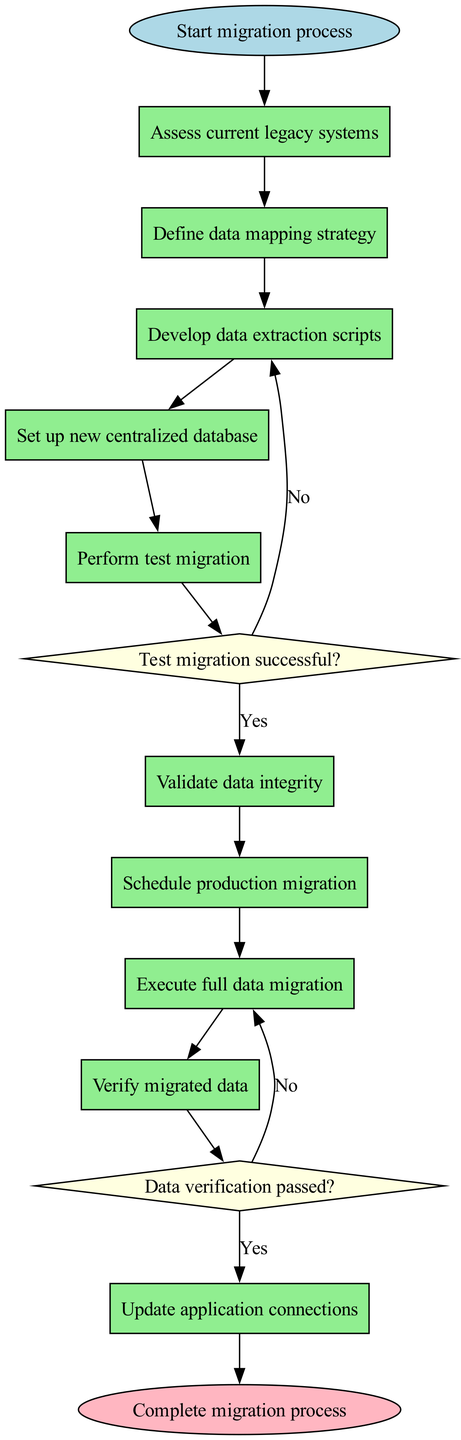What is the first activity in the migration process? The diagram starts with the initial node labeled "Start migration process," which connects to the first activity. The first activity listed in the diagram is "Assess current legacy systems."
Answer: Assess current legacy systems How many activities are in the migration process? The diagram lists a total of ten activities in the migration process from start to finish. By counting each activity listed in the activities array, we find there are ten distinct activities.
Answer: Ten What is the decision made after performing the test migration? After performing the test migration, the decision node asks, "Test migration successful?" If the answer is 'Yes', the next node is "Schedule production migration." If 'No', it connects back to "Refine extraction scripts." The first option is the one that proceeds if successful.
Answer: Schedule production migration Which activity follows after validating data integrity? "Validate data integrity" is the sixth activity in the sequence. The next activity following it is "Schedule production migration," as indicated by the connections in the flow sequence of the diagram.
Answer: Schedule production migration What happens if data verification fails? The diagram shows that if "Data verification passed?" is answered 'No', the next step is "Investigate discrepancies." This flow indicates the corrective measure taken when verification does not meet the required standards.
Answer: Investigate discrepancies How many decision nodes are present in the diagram? There are two decision nodes in the migration procedure: one after performing the test migration and another after verifying migrated data. Each decision requires a response leading to different paths in the process.
Answer: Two What is the last action before completing the migration process? The last action before completing the migration process, as shown in the diagram, is "Update application connections." This is the final node that leads to the conclusion of the migration process.
Answer: Update application connections What is the outcome if the test migration is not successful? If the test migration is not successful, the diagram indicates that the process moves to "Refine extraction scripts." This implies a need to improve the data extraction approach before proceeding further.
Answer: Refine extraction scripts How does the flow of activities progress after the setup of the new centralized database? After the "Set up new centralized database" activity, the flow progresses sequentially to "Perform test migration," which continues until it reaches the decision point. This illustrates the linear progression of tasks following the database setup.
Answer: Perform test migration 